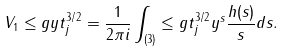Convert formula to latex. <formula><loc_0><loc_0><loc_500><loc_500>V _ { 1 } \leq g { y } { t _ { j } ^ { 3 / 2 } } = \frac { 1 } { 2 \pi i } \int _ { ( 3 ) } \leq g { t _ { j } ^ { 3 / 2 } } { y } ^ { s } \frac { h ( s ) } { s } d s .</formula> 